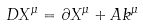<formula> <loc_0><loc_0><loc_500><loc_500>D X ^ { \mu } = \partial X ^ { \mu } + A k ^ { \mu }</formula> 